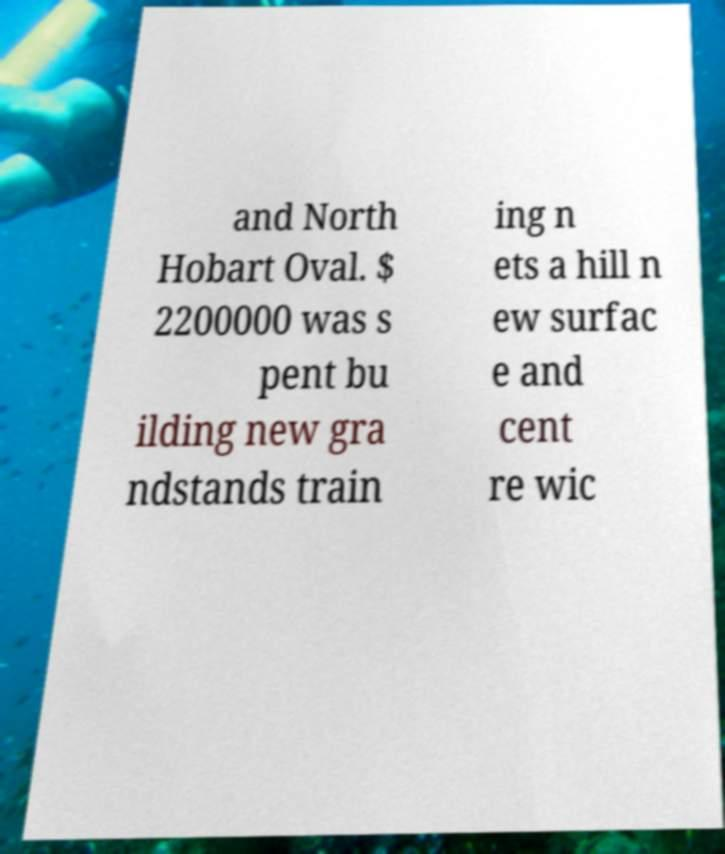Could you extract and type out the text from this image? and North Hobart Oval. $ 2200000 was s pent bu ilding new gra ndstands train ing n ets a hill n ew surfac e and cent re wic 